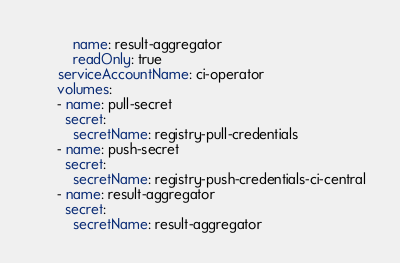Convert code to text. <code><loc_0><loc_0><loc_500><loc_500><_YAML_>          name: result-aggregator
          readOnly: true
      serviceAccountName: ci-operator
      volumes:
      - name: pull-secret
        secret:
          secretName: registry-pull-credentials
      - name: push-secret
        secret:
          secretName: registry-push-credentials-ci-central
      - name: result-aggregator
        secret:
          secretName: result-aggregator
</code> 